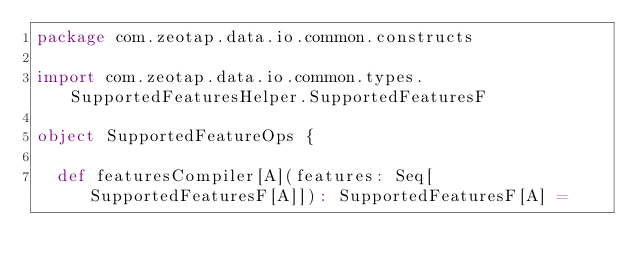Convert code to text. <code><loc_0><loc_0><loc_500><loc_500><_Scala_>package com.zeotap.data.io.common.constructs

import com.zeotap.data.io.common.types.SupportedFeaturesHelper.SupportedFeaturesF

object SupportedFeatureOps {

  def featuresCompiler[A](features: Seq[SupportedFeaturesF[A]]): SupportedFeaturesF[A] =</code> 